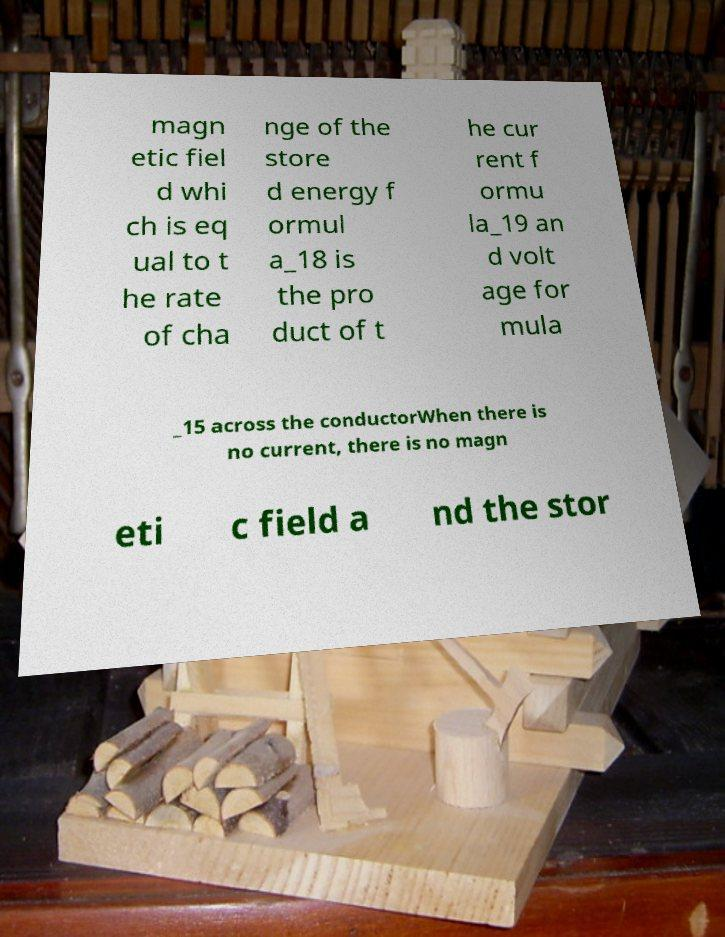I need the written content from this picture converted into text. Can you do that? magn etic fiel d whi ch is eq ual to t he rate of cha nge of the store d energy f ormul a_18 is the pro duct of t he cur rent f ormu la_19 an d volt age for mula _15 across the conductorWhen there is no current, there is no magn eti c field a nd the stor 